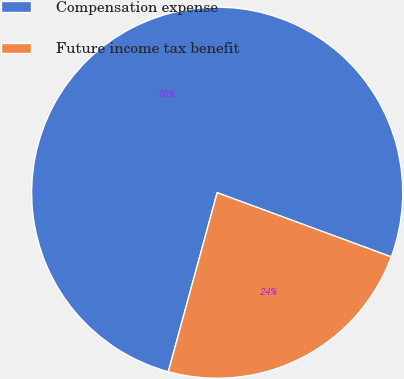Convert chart to OTSL. <chart><loc_0><loc_0><loc_500><loc_500><pie_chart><fcel>Compensation expense<fcel>Future income tax benefit<nl><fcel>76.38%<fcel>23.62%<nl></chart> 